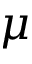<formula> <loc_0><loc_0><loc_500><loc_500>\mu</formula> 